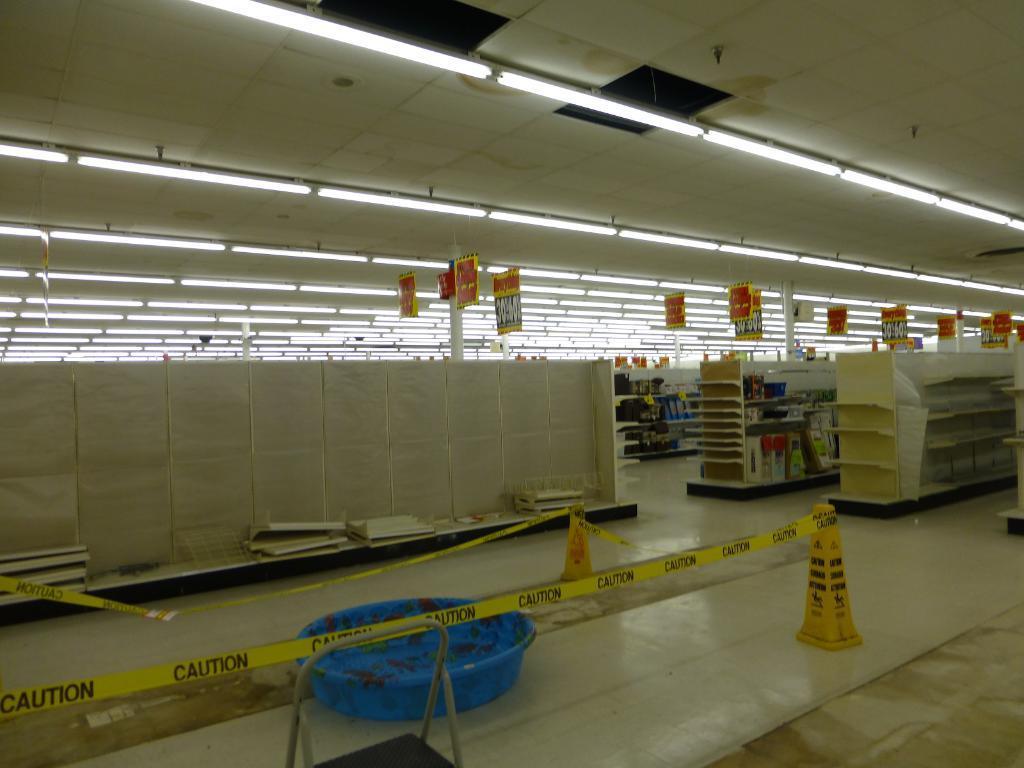Can you describe this image briefly? The picture is clicked in a building. In this picture there are ladder and other objects. On the right there are shelves. At the top there are banners and lights. 